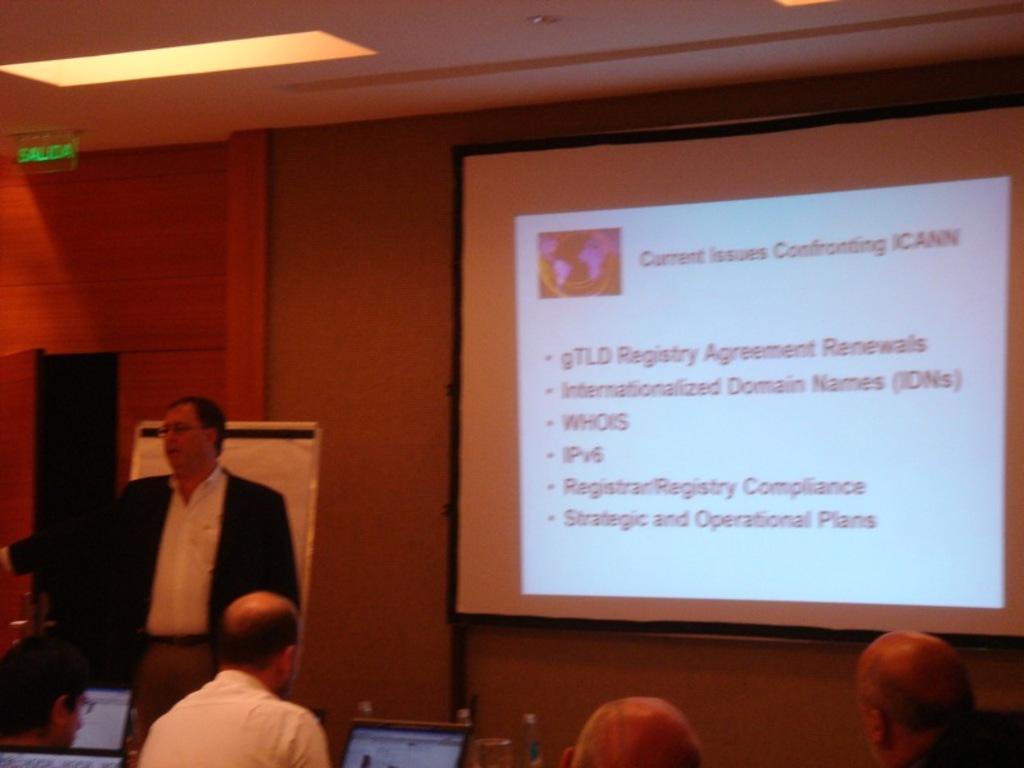Can you describe this image briefly? On the left side a person is standing. Also there are many people sitting. In front of them there are laptops and bottles. In the back there is a wall with a screen. On the ceiling there is a light. Also there is a name board. 